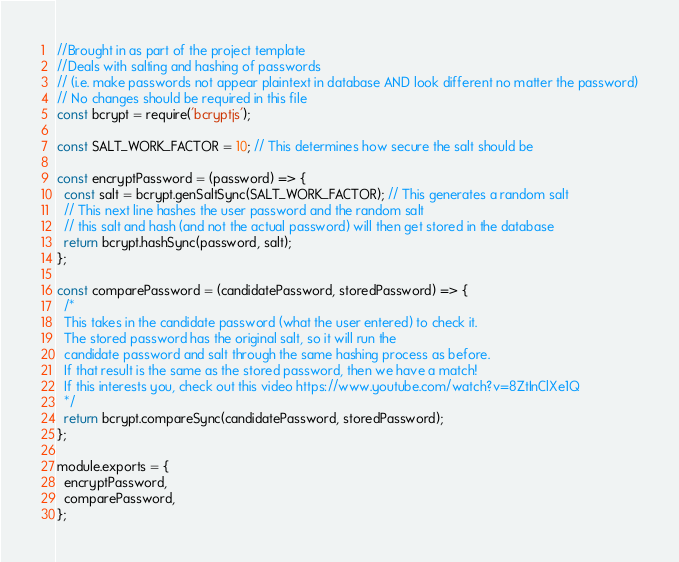<code> <loc_0><loc_0><loc_500><loc_500><_JavaScript_>//Brought in as part of the project template
//Deals with salting and hashing of passwords 
// (i.e. make passwords not appear plaintext in database AND look different no matter the password)
// No changes should be required in this file
const bcrypt = require('bcryptjs');

const SALT_WORK_FACTOR = 10; // This determines how secure the salt should be

const encryptPassword = (password) => {
  const salt = bcrypt.genSaltSync(SALT_WORK_FACTOR); // This generates a random salt
  // This next line hashes the user password and the random salt
  // this salt and hash (and not the actual password) will then get stored in the database
  return bcrypt.hashSync(password, salt);
};

const comparePassword = (candidatePassword, storedPassword) => {
  /*
  This takes in the candidate password (what the user entered) to check it.
  The stored password has the original salt, so it will run the
  candidate password and salt through the same hashing process as before.
  If that result is the same as the stored password, then we have a match!
  If this interests you, check out this video https://www.youtube.com/watch?v=8ZtInClXe1Q
  */
  return bcrypt.compareSync(candidatePassword, storedPassword);
};

module.exports = {
  encryptPassword,
  comparePassword,
};
</code> 